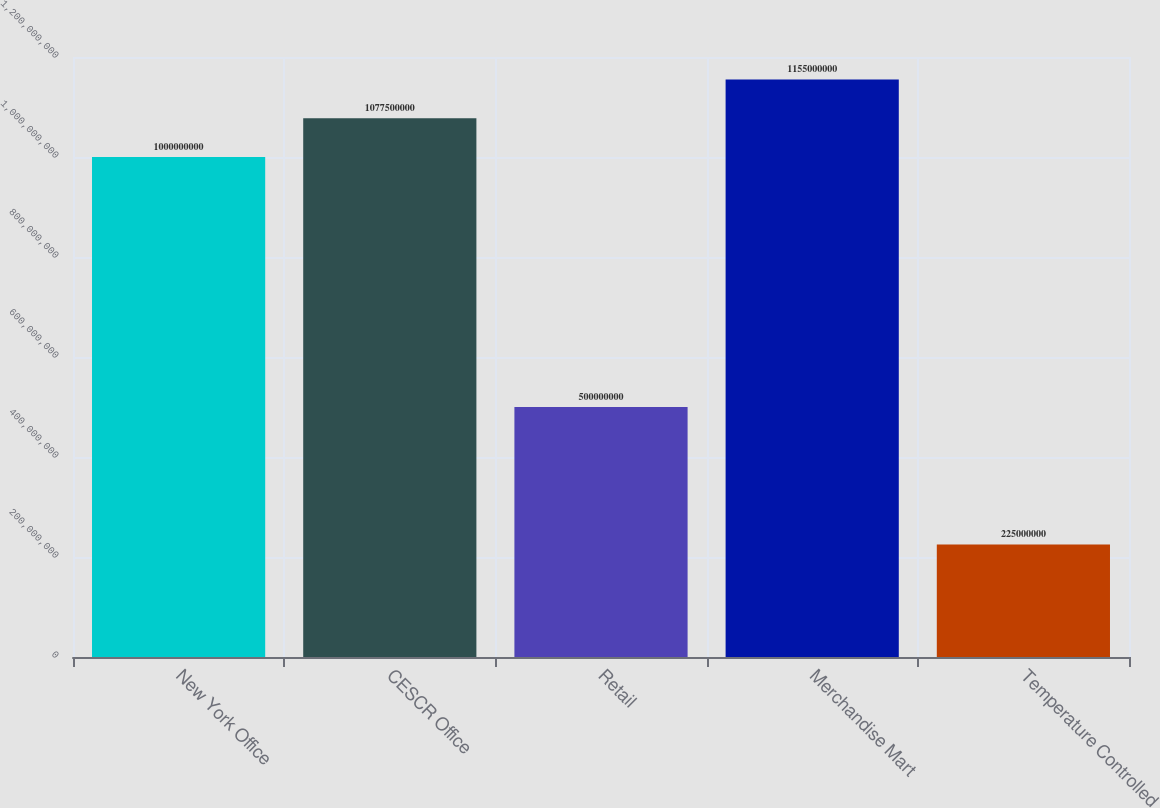<chart> <loc_0><loc_0><loc_500><loc_500><bar_chart><fcel>New York Office<fcel>CESCR Office<fcel>Retail<fcel>Merchandise Mart<fcel>Temperature Controlled<nl><fcel>1e+09<fcel>1.0775e+09<fcel>5e+08<fcel>1.155e+09<fcel>2.25e+08<nl></chart> 